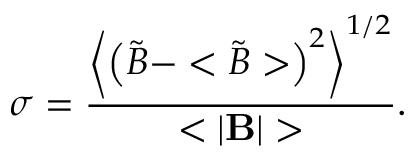Convert formula to latex. <formula><loc_0><loc_0><loc_500><loc_500>\sigma = \frac { \left < \left ( { \tilde { B } } - < { \tilde { B } } > \right ) ^ { 2 } \right > ^ { 1 / 2 } } { < | { B } | > } .</formula> 